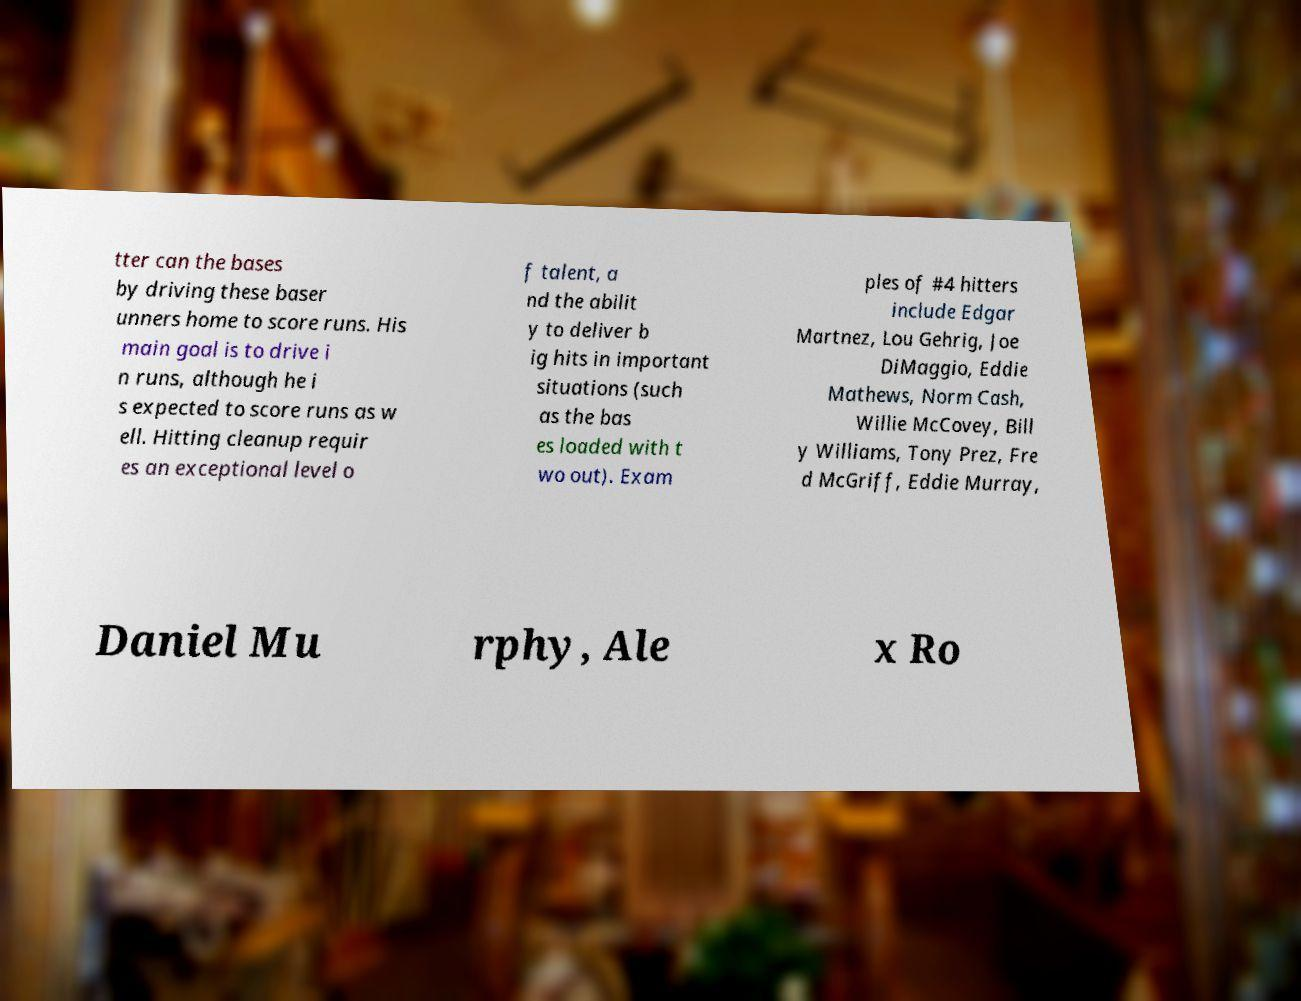Could you extract and type out the text from this image? tter can the bases by driving these baser unners home to score runs. His main goal is to drive i n runs, although he i s expected to score runs as w ell. Hitting cleanup requir es an exceptional level o f talent, a nd the abilit y to deliver b ig hits in important situations (such as the bas es loaded with t wo out). Exam ples of #4 hitters include Edgar Martnez, Lou Gehrig, Joe DiMaggio, Eddie Mathews, Norm Cash, Willie McCovey, Bill y Williams, Tony Prez, Fre d McGriff, Eddie Murray, Daniel Mu rphy, Ale x Ro 